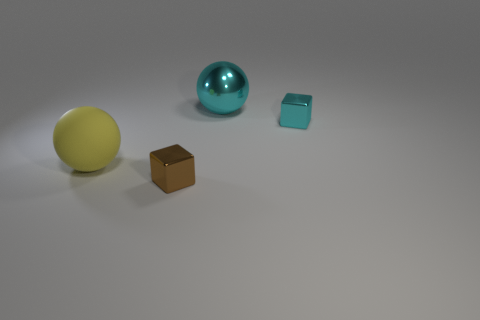Add 3 tiny brown metallic blocks. How many objects exist? 7 Subtract 1 cubes. How many cubes are left? 1 Add 4 big yellow matte objects. How many big yellow matte objects are left? 5 Add 4 blocks. How many blocks exist? 6 Subtract all yellow balls. How many balls are left? 1 Subtract 0 gray blocks. How many objects are left? 4 Subtract all gray spheres. Subtract all brown cylinders. How many spheres are left? 2 Subtract all green cylinders. How many yellow cubes are left? 0 Subtract all big rubber objects. Subtract all brown metallic blocks. How many objects are left? 2 